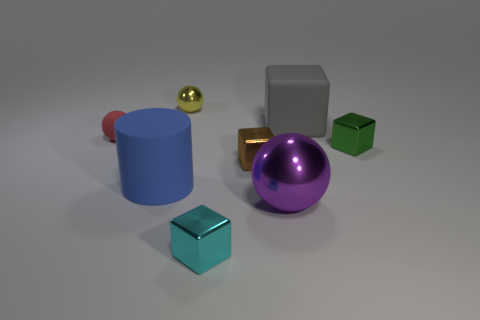Add 2 large red shiny balls. How many objects exist? 10 Subtract all cylinders. How many objects are left? 7 Subtract 0 gray cylinders. How many objects are left? 8 Subtract all big purple metallic spheres. Subtract all tiny red rubber balls. How many objects are left? 6 Add 5 gray objects. How many gray objects are left? 6 Add 4 large gray cubes. How many large gray cubes exist? 5 